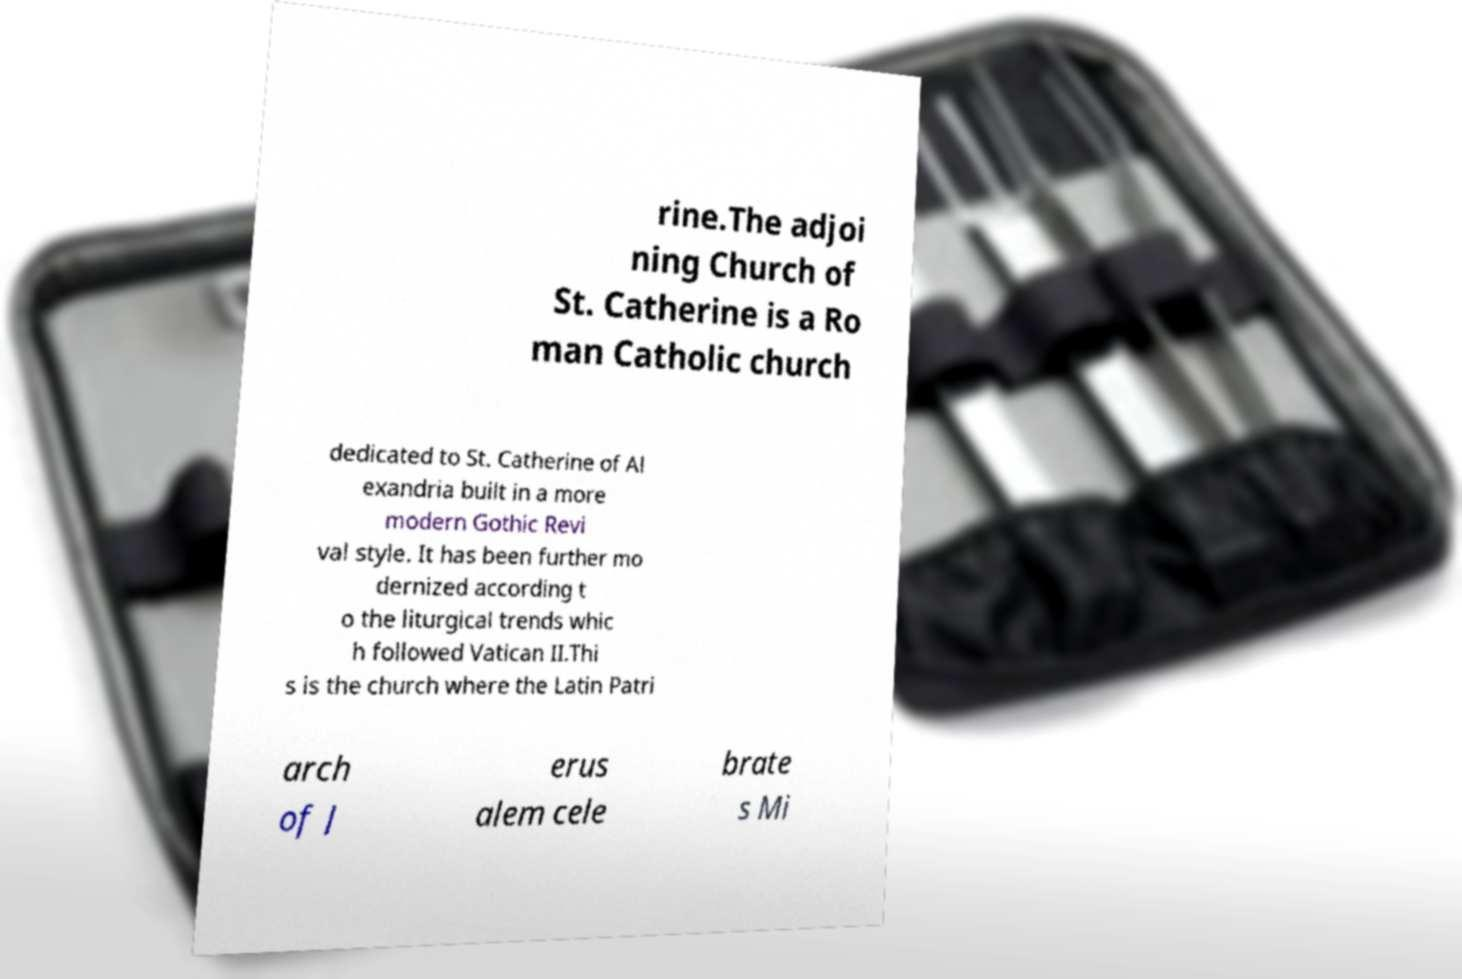I need the written content from this picture converted into text. Can you do that? rine.The adjoi ning Church of St. Catherine is a Ro man Catholic church dedicated to St. Catherine of Al exandria built in a more modern Gothic Revi val style. It has been further mo dernized according t o the liturgical trends whic h followed Vatican II.Thi s is the church where the Latin Patri arch of J erus alem cele brate s Mi 